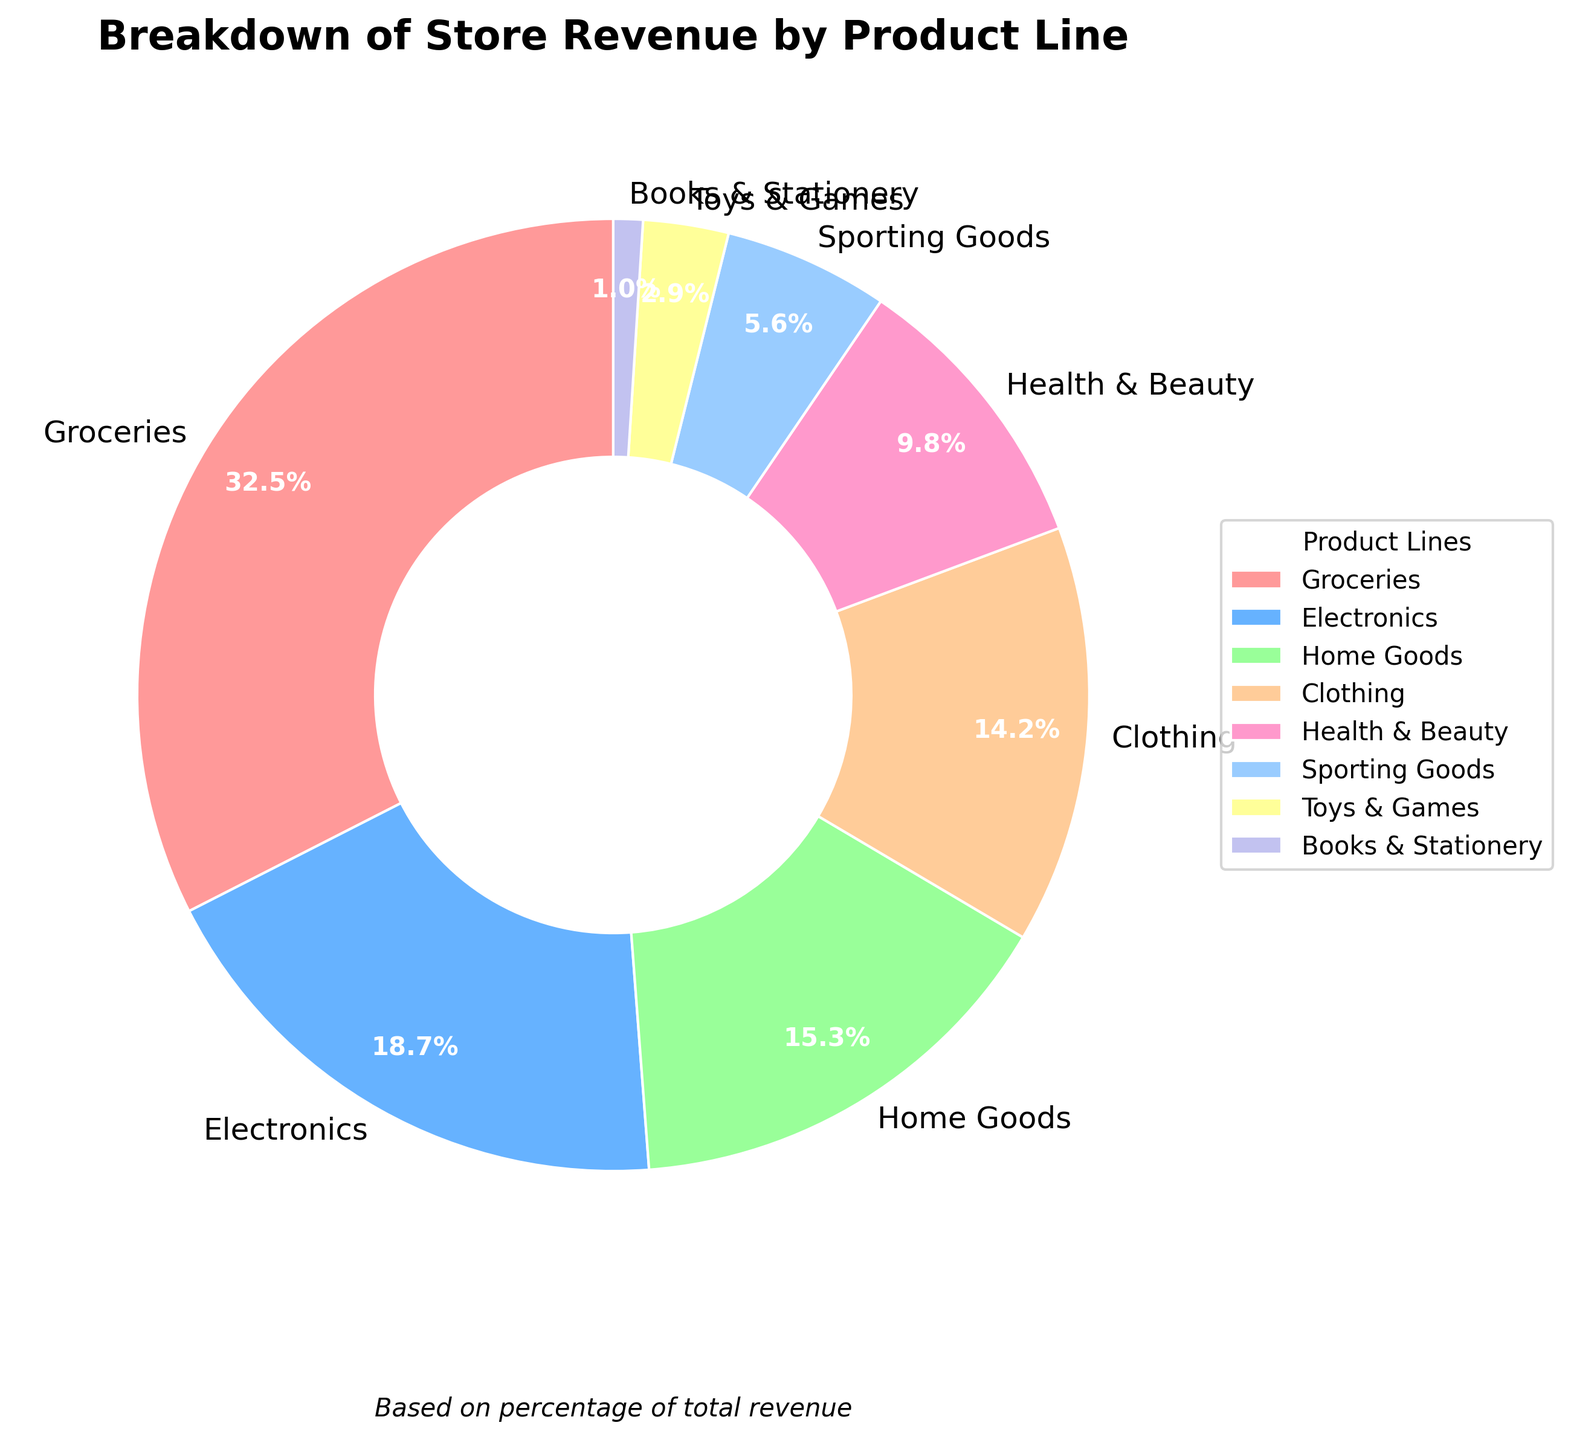What product line has the highest percentage of store revenue? The figure shows that Groceries has the largest segment representing 32.5% of the total revenue.
Answer: Groceries Which product line contributes the least to the store revenue? The smallest segment in the pie chart represents Books & Stationery with 1.0% of the total revenue.
Answer: Books & Stationery How much more revenue does Groceries generate compared to Electronics? Groceries generates 32.5% of the revenue, while Electronics generates 18.7%. The difference is 32.5% - 18.7% = 13.8%.
Answer: 13.8% If the store's total revenue is $1,000,000, how much revenue is generated from Clothing and Home Goods combined? Home Goods contribute 15.3% and Clothing contributes 14.2%. Together, they contribute 15.3% + 14.2% = 29.5% of the total revenue. 29.5% of $1,000,000 is 0.295 * $1,000,000 = $295,000.
Answer: $295,000 Which product lines generate more than 10% of the store revenue? By examining the pie chart, the segments for Groceries (32.5%), Electronics (18.7%), Home Goods (15.3%), and Clothing (14.2%) are all greater than 10%.
Answer: Groceries, Electronics, Home Goods, Clothing How does the revenue from Sporting Goods compare to Health & Beauty? Sporting Goods contributes 5.6% of the revenue, whereas Health & Beauty contributes 9.8%. Health & Beauty generates a higher percentage of the revenue than Sporting Goods.
Answer: Health & Beauty generates more What percent of the total revenue is generated by the five least contributing product lines? The five least contributing product lines are Health & Beauty (9.8%), Sporting Goods (5.6%), Toys & Games (2.9%), and Books & Stationery (1.0%). Their combined percentage is 9.8% + 5.6% + 2.9% + 1.0% = 19.3%.
Answer: 19.3% Which product line, among Health & Beauty and Electronics, generates a higher revenue percentage? The pie chart shows that Health & Beauty generates 9.8%, while Electronics generates 18.7% of the total revenue. Electronics generates a higher percentage of revenue.
Answer: Electronics 